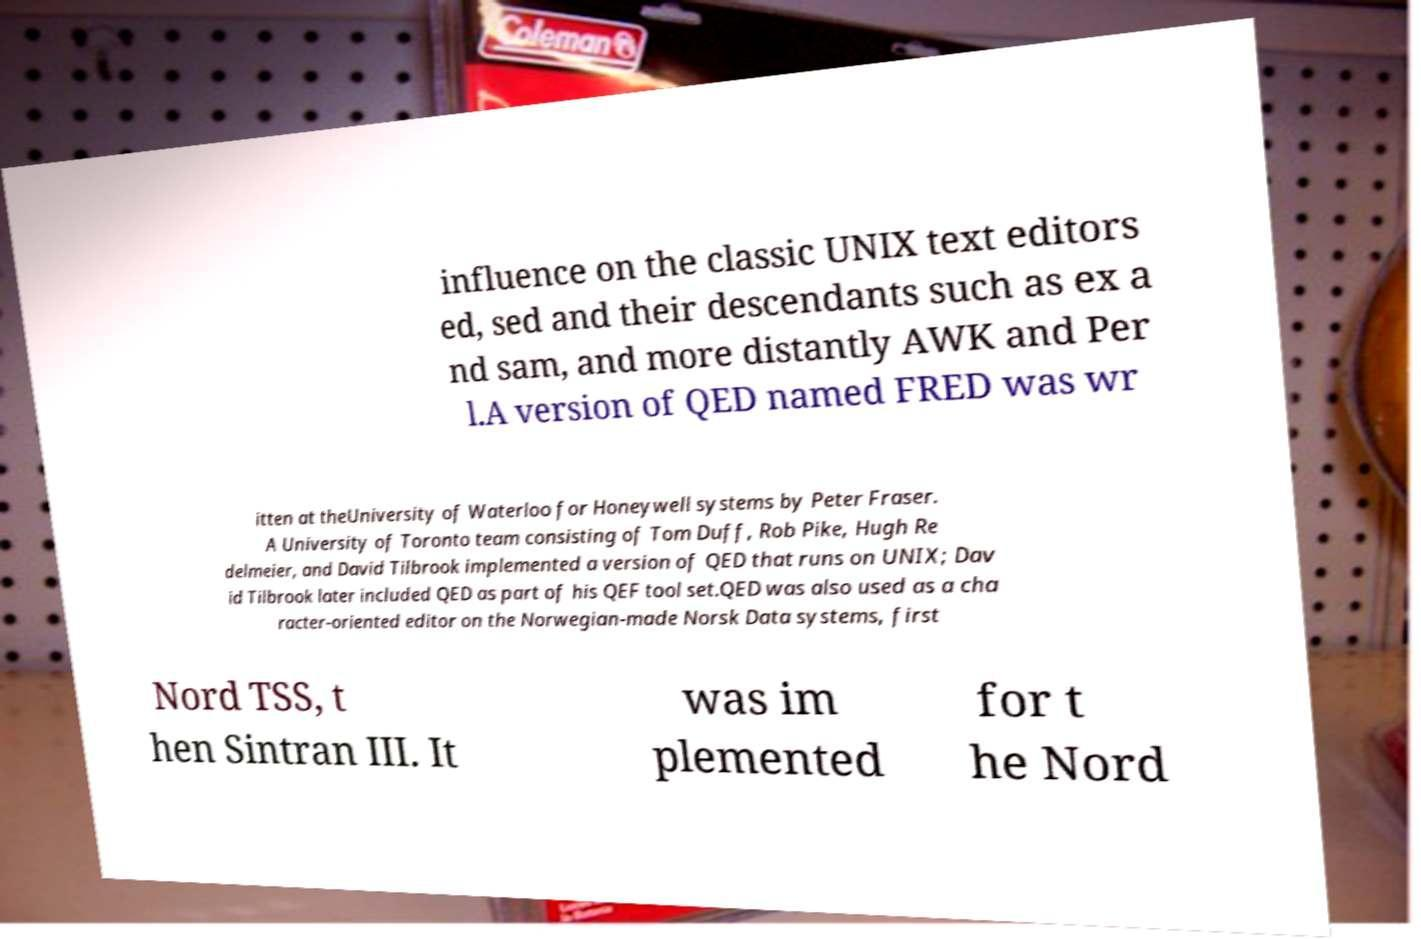What messages or text are displayed in this image? I need them in a readable, typed format. influence on the classic UNIX text editors ed, sed and their descendants such as ex a nd sam, and more distantly AWK and Per l.A version of QED named FRED was wr itten at theUniversity of Waterloo for Honeywell systems by Peter Fraser. A University of Toronto team consisting of Tom Duff, Rob Pike, Hugh Re delmeier, and David Tilbrook implemented a version of QED that runs on UNIX; Dav id Tilbrook later included QED as part of his QEF tool set.QED was also used as a cha racter-oriented editor on the Norwegian-made Norsk Data systems, first Nord TSS, t hen Sintran III. It was im plemented for t he Nord 